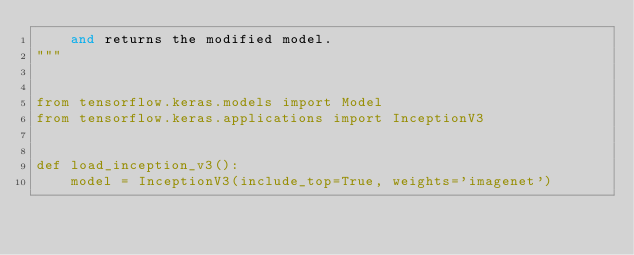<code> <loc_0><loc_0><loc_500><loc_500><_Python_>    and returns the modified model.
"""


from tensorflow.keras.models import Model
from tensorflow.keras.applications import InceptionV3


def load_inception_v3():
    model = InceptionV3(include_top=True, weights='imagenet')</code> 